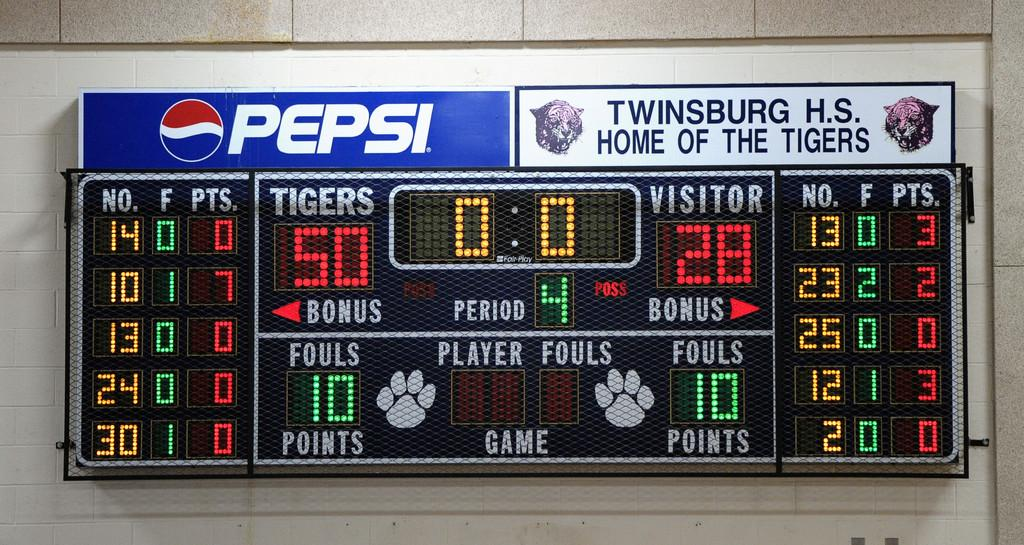<image>
Present a compact description of the photo's key features. The score at the Twinsburg H.S. basketball game is Tigers 50 Visitors 28. 